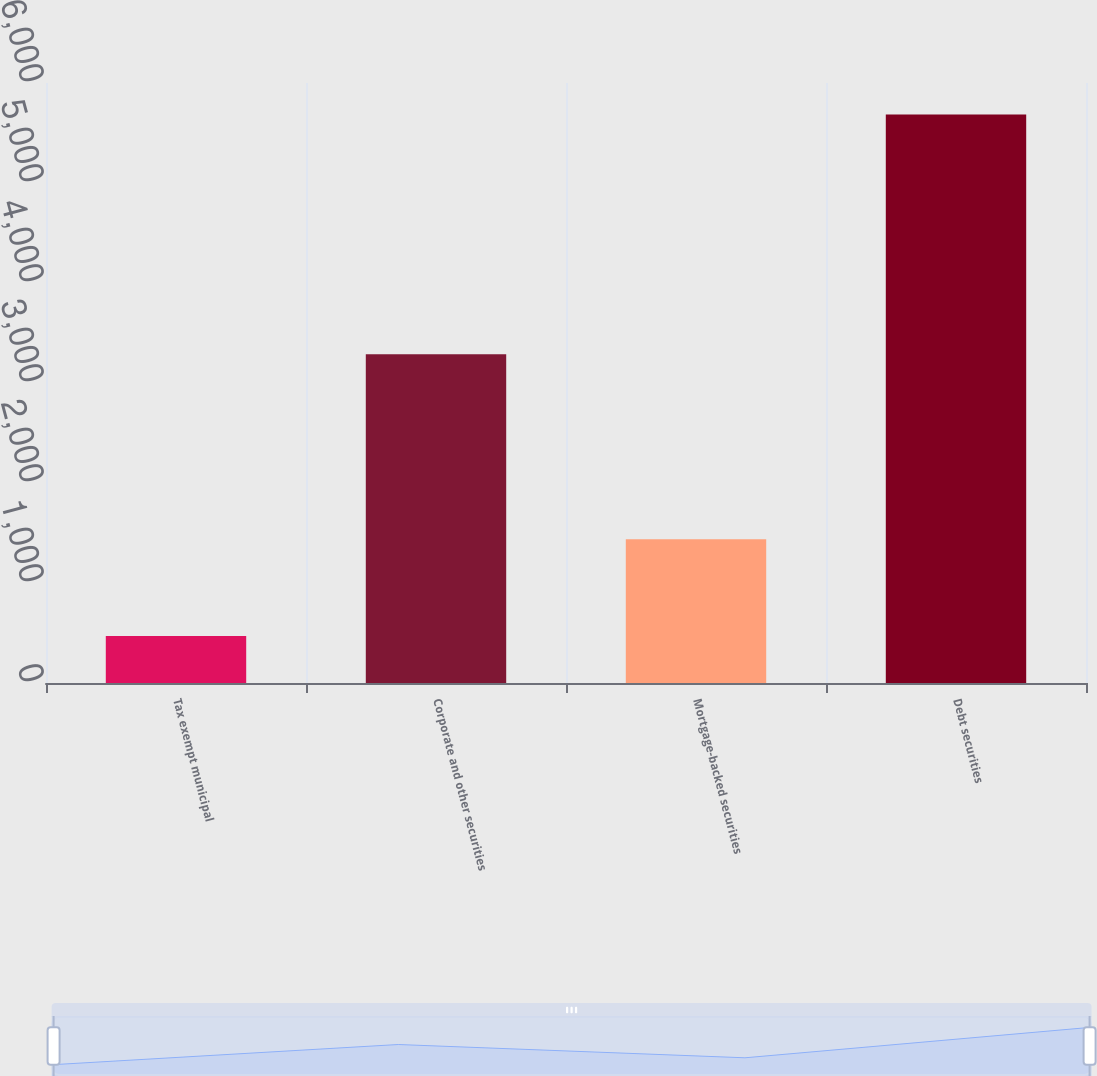Convert chart to OTSL. <chart><loc_0><loc_0><loc_500><loc_500><bar_chart><fcel>Tax exempt municipal<fcel>Corporate and other securities<fcel>Mortgage-backed securities<fcel>Debt securities<nl><fcel>471<fcel>3287<fcel>1438<fcel>5686<nl></chart> 